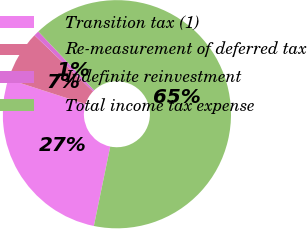Convert chart. <chart><loc_0><loc_0><loc_500><loc_500><pie_chart><fcel>Transition tax (1)<fcel>Re-measurement of deferred tax<fcel>Indefinite reinvestment<fcel>Total income tax expense<nl><fcel>26.73%<fcel>7.2%<fcel>0.74%<fcel>65.33%<nl></chart> 